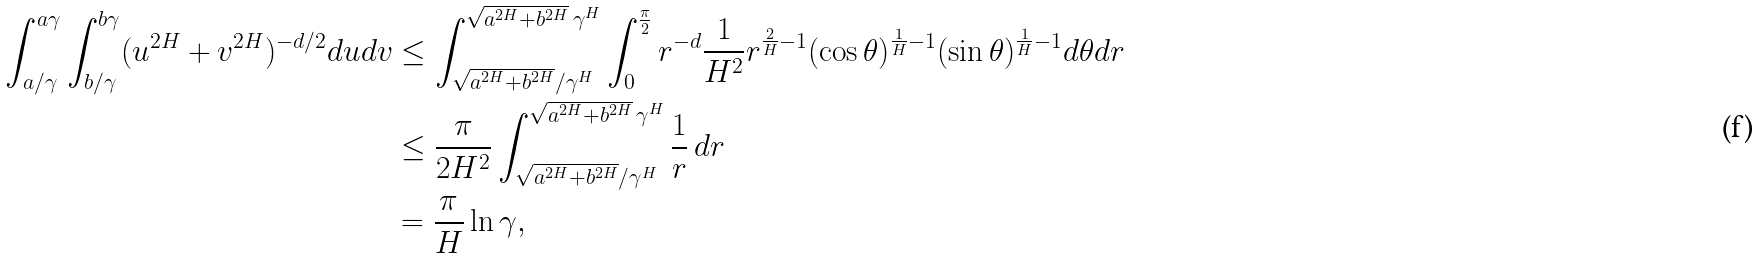Convert formula to latex. <formula><loc_0><loc_0><loc_500><loc_500>\int _ { a / \gamma } ^ { a \gamma } \int _ { b / \gamma } ^ { b \gamma } ( u ^ { 2 H } + v ^ { 2 H } ) ^ { - d / 2 } d u d v & \leq \int ^ { \sqrt { a ^ { 2 H } + b ^ { 2 H } } \, \gamma ^ { H } } _ { \sqrt { a ^ { 2 H } + b ^ { 2 H } } / \gamma ^ { H } } \int ^ { \frac { \pi } { 2 } } _ { 0 } r ^ { - d } \frac { 1 } { H ^ { 2 } } r ^ { \frac { 2 } { H } - 1 } ( \cos \theta ) ^ { \frac { 1 } { H } - 1 } ( \sin \theta ) ^ { \frac { 1 } { H } - 1 } d \theta d r \\ & \leq \frac { \pi } { 2 H ^ { 2 } } \int ^ { \sqrt { a ^ { 2 H } + b ^ { 2 H } } \, \gamma ^ { H } } _ { \sqrt { a ^ { 2 H } + b ^ { 2 H } } / \gamma ^ { H } } \frac { 1 } { r } \, d r \\ & = \frac { \pi } { H } \ln \gamma ,</formula> 